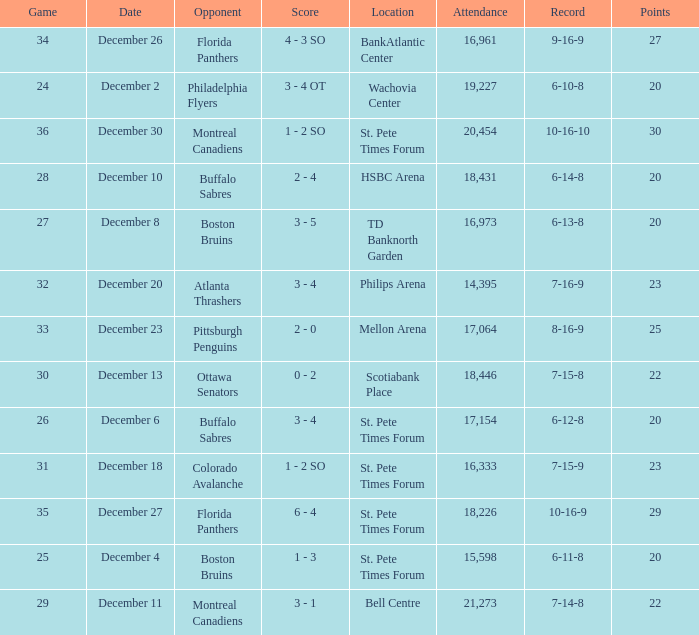What game has a 6-12-8 record? 26.0. 